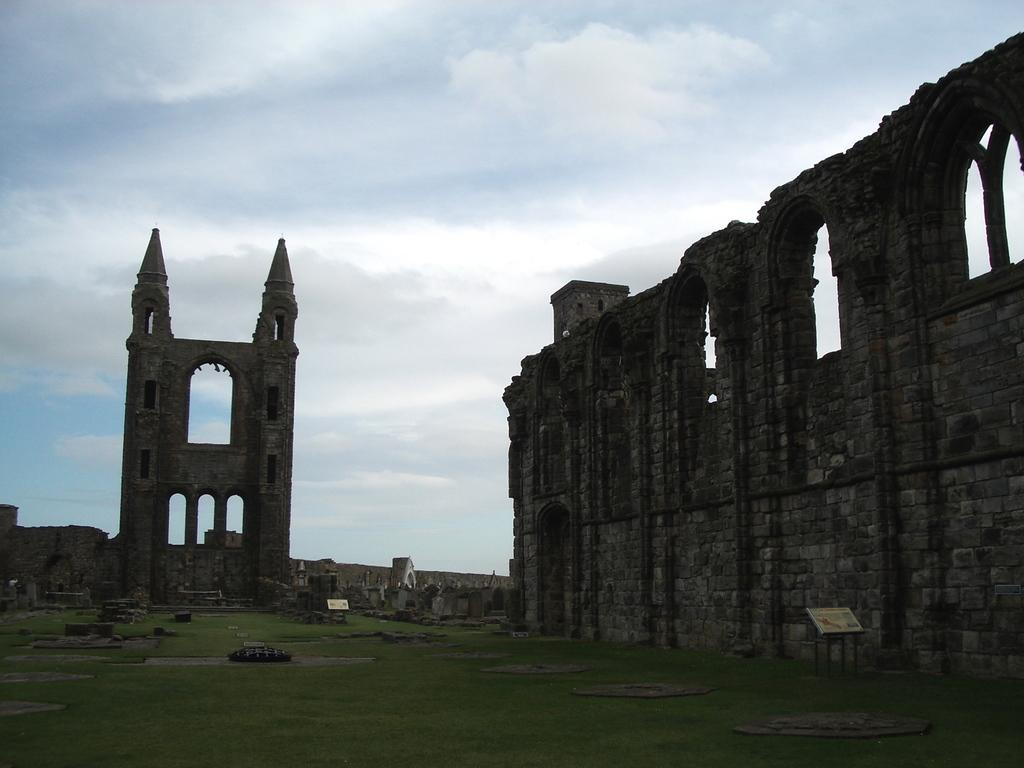What is the main subject of the picture? There is a monument in the picture. What type of surface is visible on the ground? There is grass on the ground. What can be seen in the sky in the background of the image? There are clouds in the sky in the background of the image. What emotion is the monument expressing in the image? Monuments do not express emotions; they are inanimate objects. 